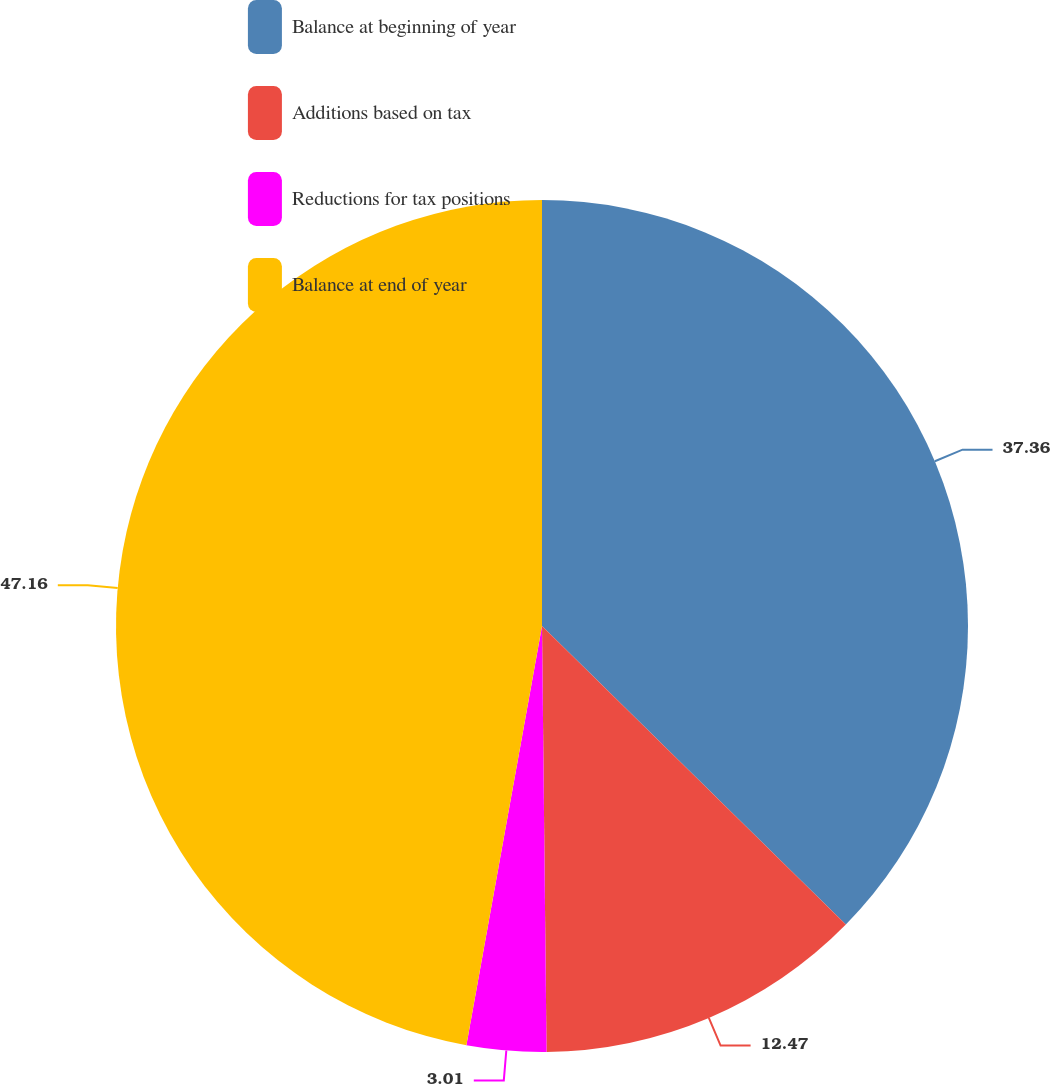Convert chart. <chart><loc_0><loc_0><loc_500><loc_500><pie_chart><fcel>Balance at beginning of year<fcel>Additions based on tax<fcel>Reductions for tax positions<fcel>Balance at end of year<nl><fcel>37.36%<fcel>12.47%<fcel>3.01%<fcel>47.16%<nl></chart> 